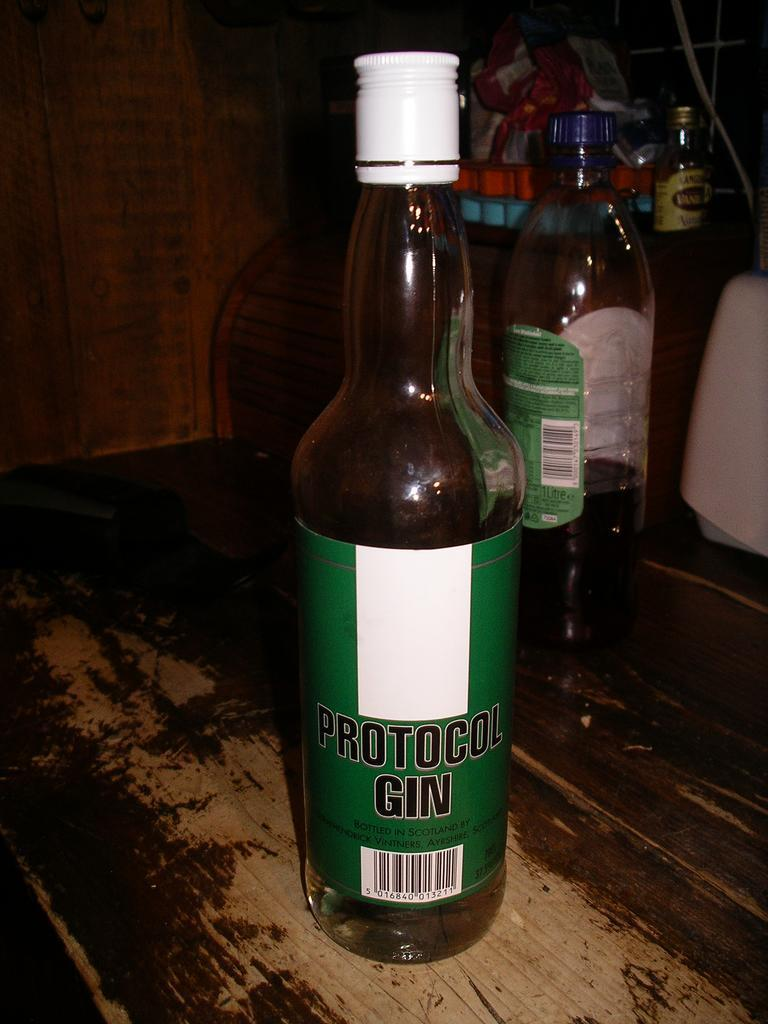<image>
Create a compact narrative representing the image presented. the words protocol gin that are on a drink 